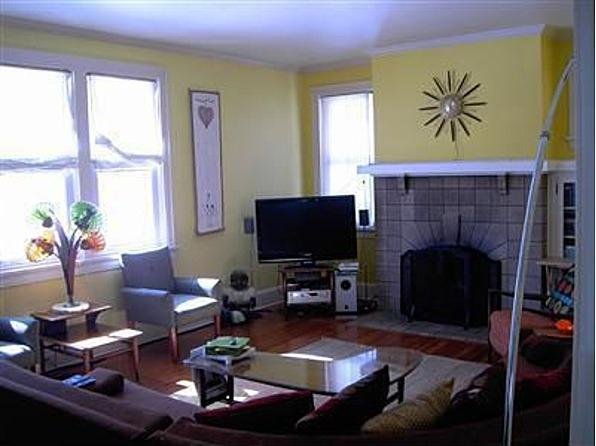Is the fireplace lit?
Answer briefly. No. Is there a laptop on the table?
Give a very brief answer. No. What is shown on the TV screen?
Quick response, please. Nothing. What color is the wall painted?
Keep it brief. Yellow. Is this a classroom?
Quick response, please. No. Is it sunny out?
Give a very brief answer. Yes. 